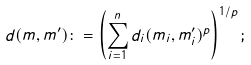<formula> <loc_0><loc_0><loc_500><loc_500>d ( m , m ^ { \prime } ) \colon = \left ( \sum _ { i = 1 } ^ { n } d _ { i } ( m _ { i } , m _ { i } ^ { \prime } ) ^ { p } \right ) ^ { 1 / p } ;</formula> 